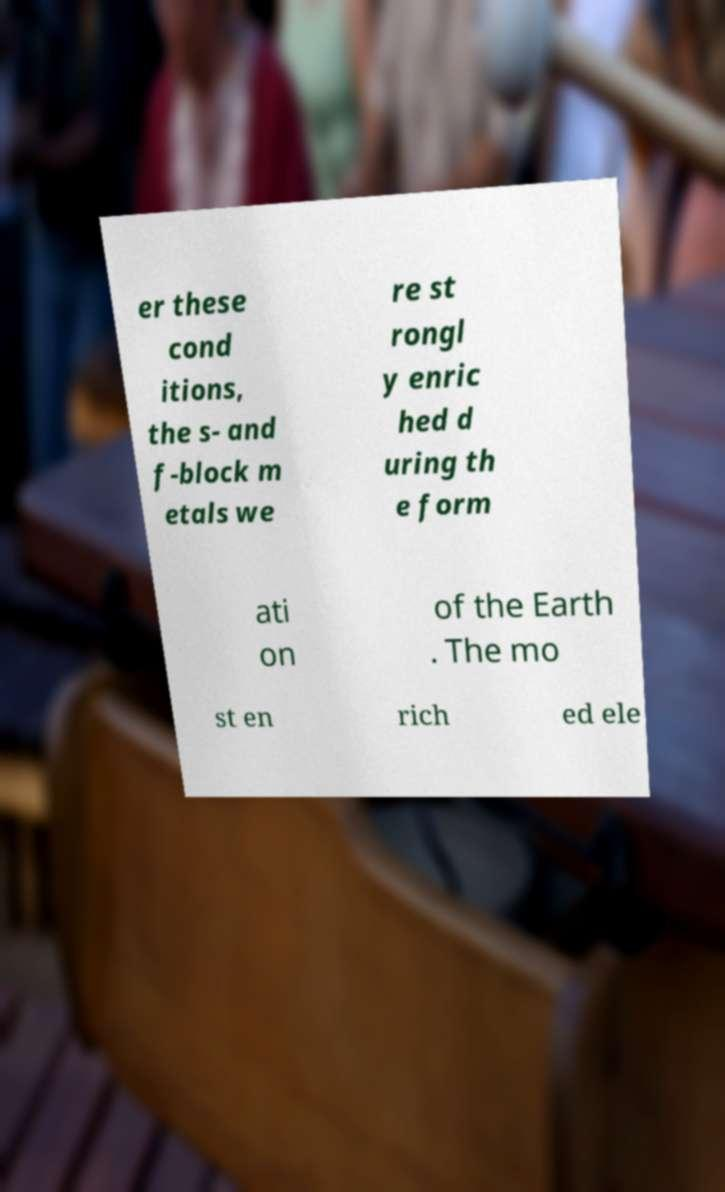For documentation purposes, I need the text within this image transcribed. Could you provide that? er these cond itions, the s- and f-block m etals we re st rongl y enric hed d uring th e form ati on of the Earth . The mo st en rich ed ele 